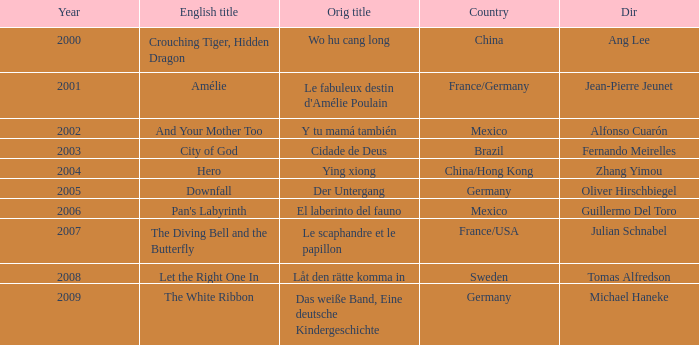Can you provide the title of jean-pierre jeunet? Amélie. 